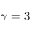Convert formula to latex. <formula><loc_0><loc_0><loc_500><loc_500>\gamma = 3</formula> 